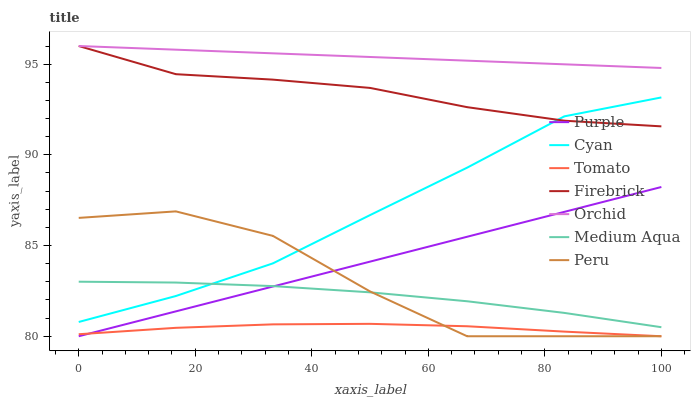Does Tomato have the minimum area under the curve?
Answer yes or no. Yes. Does Orchid have the maximum area under the curve?
Answer yes or no. Yes. Does Purple have the minimum area under the curve?
Answer yes or no. No. Does Purple have the maximum area under the curve?
Answer yes or no. No. Is Orchid the smoothest?
Answer yes or no. Yes. Is Peru the roughest?
Answer yes or no. Yes. Is Purple the smoothest?
Answer yes or no. No. Is Purple the roughest?
Answer yes or no. No. Does Firebrick have the lowest value?
Answer yes or no. No. Does Orchid have the highest value?
Answer yes or no. Yes. Does Purple have the highest value?
Answer yes or no. No. Is Peru less than Orchid?
Answer yes or no. Yes. Is Orchid greater than Purple?
Answer yes or no. Yes. Does Cyan intersect Medium Aqua?
Answer yes or no. Yes. Is Cyan less than Medium Aqua?
Answer yes or no. No. Is Cyan greater than Medium Aqua?
Answer yes or no. No. Does Peru intersect Orchid?
Answer yes or no. No. 